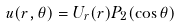Convert formula to latex. <formula><loc_0><loc_0><loc_500><loc_500>u ( r , \theta ) = U _ { r } ( r ) P _ { 2 } ( \cos \theta )</formula> 